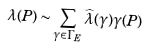<formula> <loc_0><loc_0><loc_500><loc_500>\lambda ( P ) \sim \sum _ { \gamma \in \Gamma _ { E } } \widehat { \lambda } ( \gamma ) \gamma ( P )</formula> 